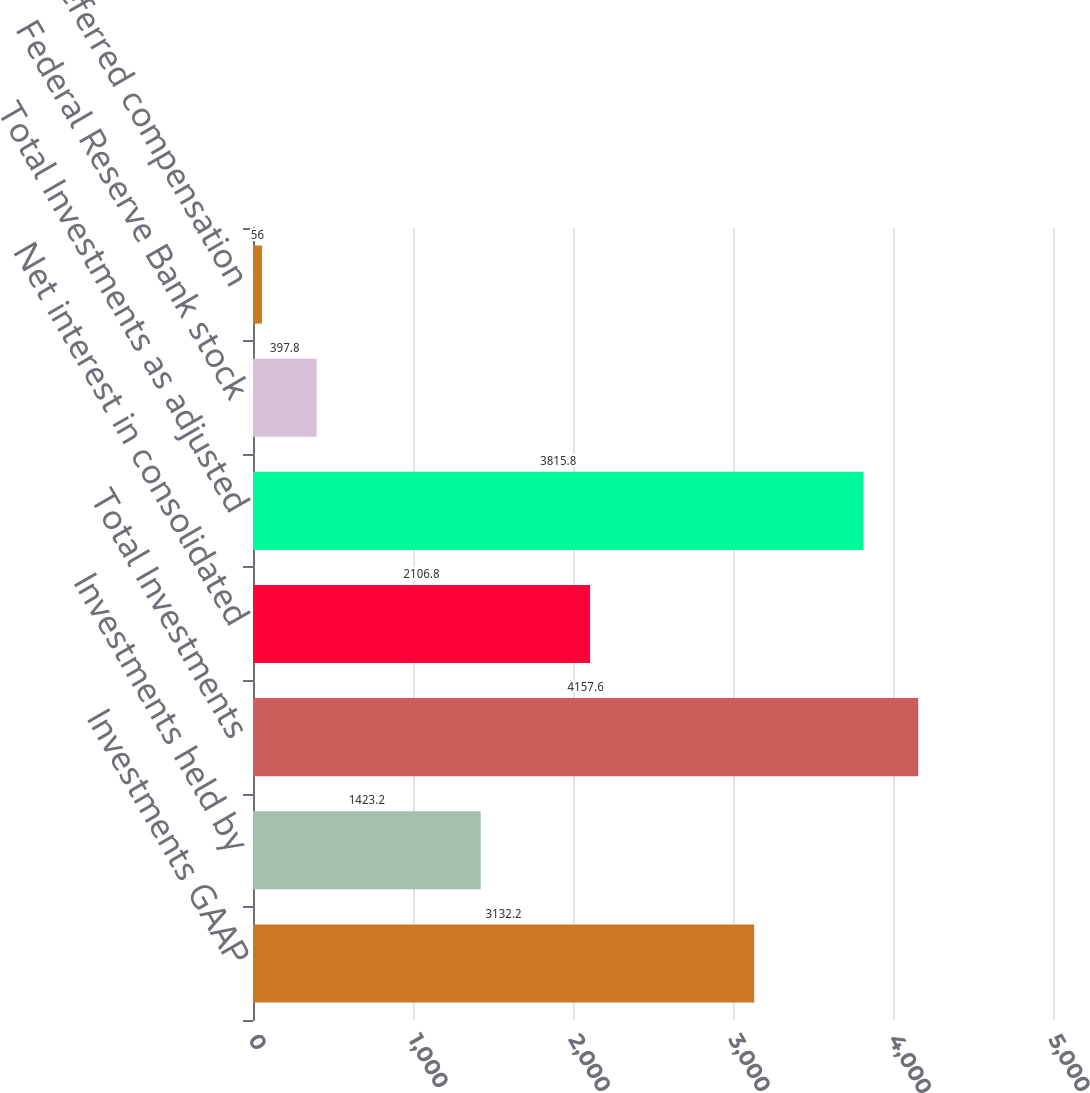Convert chart. <chart><loc_0><loc_0><loc_500><loc_500><bar_chart><fcel>Investments GAAP<fcel>Investments held by<fcel>Total Investments<fcel>Net interest in consolidated<fcel>Total Investments as adjusted<fcel>Federal Reserve Bank stock<fcel>Deferred compensation<nl><fcel>3132.2<fcel>1423.2<fcel>4157.6<fcel>2106.8<fcel>3815.8<fcel>397.8<fcel>56<nl></chart> 